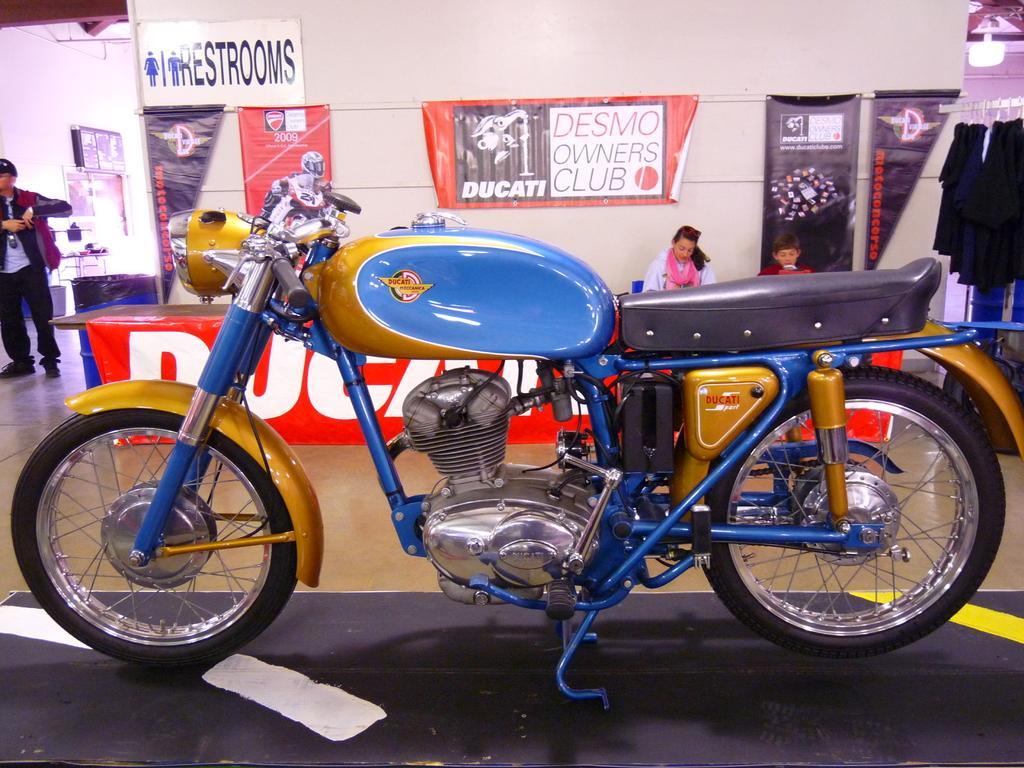Describe this image in one or two sentences. In the picture I can see the motorbike placed on the black color surface. In the background, I can see these two persons are sitting near the table, I can see banners, boards, few clothes hanged here and I can see another person on the left side of the image and I can see ceiling lights in the background. 